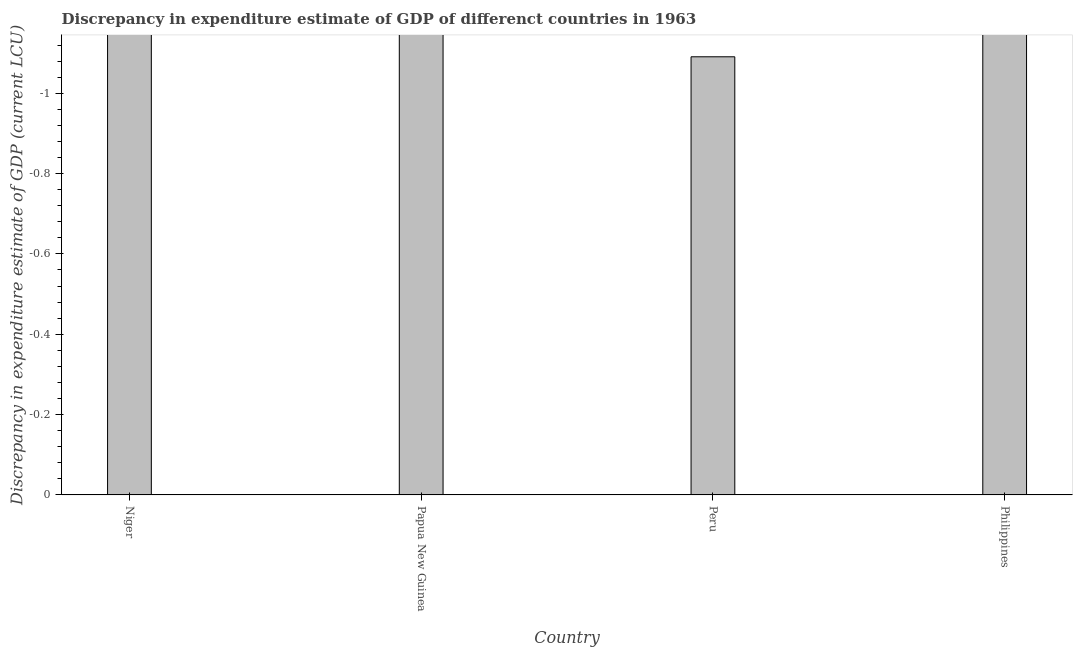What is the title of the graph?
Ensure brevity in your answer.  Discrepancy in expenditure estimate of GDP of differenct countries in 1963. What is the label or title of the X-axis?
Provide a succinct answer. Country. What is the label or title of the Y-axis?
Offer a very short reply. Discrepancy in expenditure estimate of GDP (current LCU). What is the sum of the discrepancy in expenditure estimate of gdp?
Give a very brief answer. 0. What is the median discrepancy in expenditure estimate of gdp?
Keep it short and to the point. 0. In how many countries, is the discrepancy in expenditure estimate of gdp greater than -0.04 LCU?
Give a very brief answer. 0. In how many countries, is the discrepancy in expenditure estimate of gdp greater than the average discrepancy in expenditure estimate of gdp taken over all countries?
Your answer should be compact. 0. Are all the bars in the graph horizontal?
Make the answer very short. No. What is the difference between two consecutive major ticks on the Y-axis?
Offer a terse response. 0.2. What is the Discrepancy in expenditure estimate of GDP (current LCU) of Niger?
Your answer should be compact. 0. 